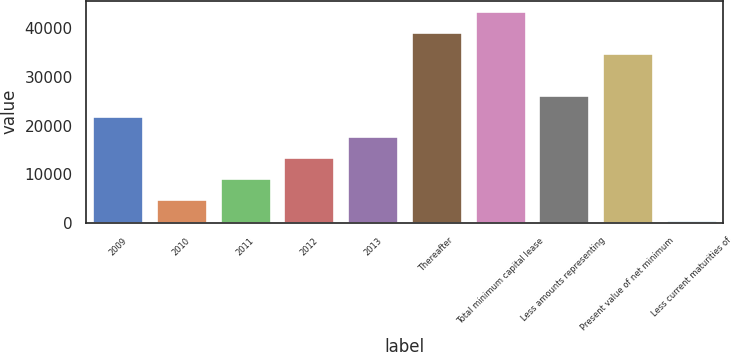Convert chart to OTSL. <chart><loc_0><loc_0><loc_500><loc_500><bar_chart><fcel>2009<fcel>2010<fcel>2011<fcel>2012<fcel>2013<fcel>Thereafter<fcel>Total minimum capital lease<fcel>Less amounts representing<fcel>Present value of net minimum<fcel>Less current maturities of<nl><fcel>22058.5<fcel>4896.5<fcel>9187<fcel>13477.5<fcel>17768<fcel>39220.5<fcel>43511<fcel>26349<fcel>34930<fcel>606<nl></chart> 